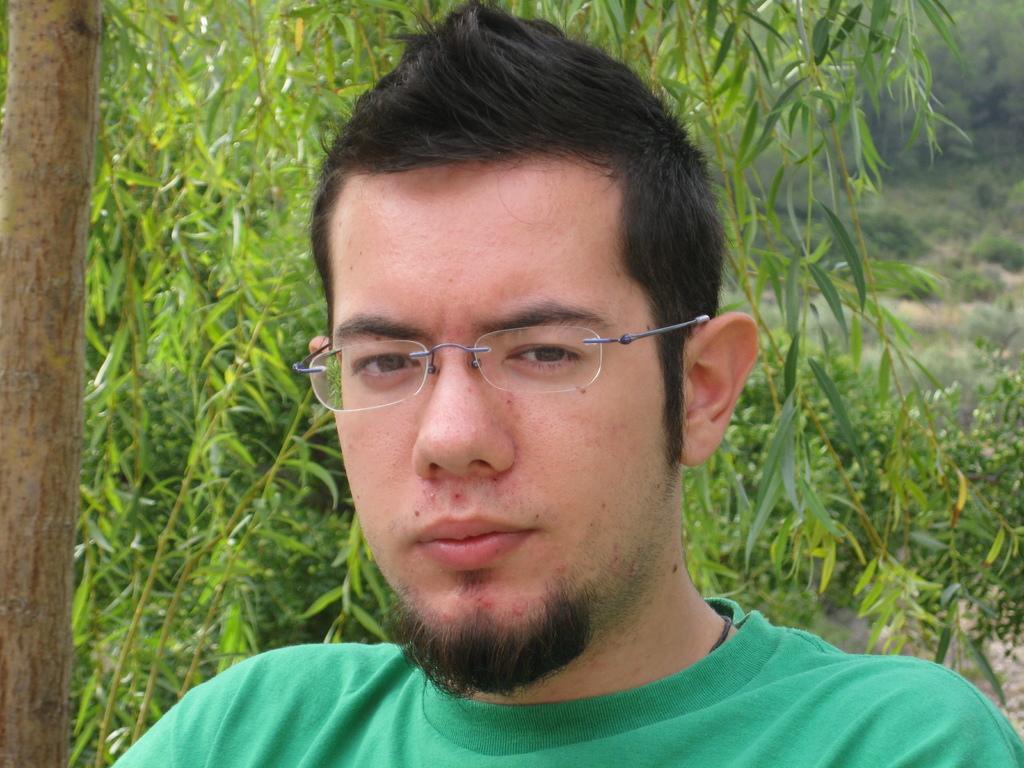Can you describe this image briefly? This image consists of a man wearing green T-shirt and specs. To the left, there is a tree. In the background, there are plants and trees. 